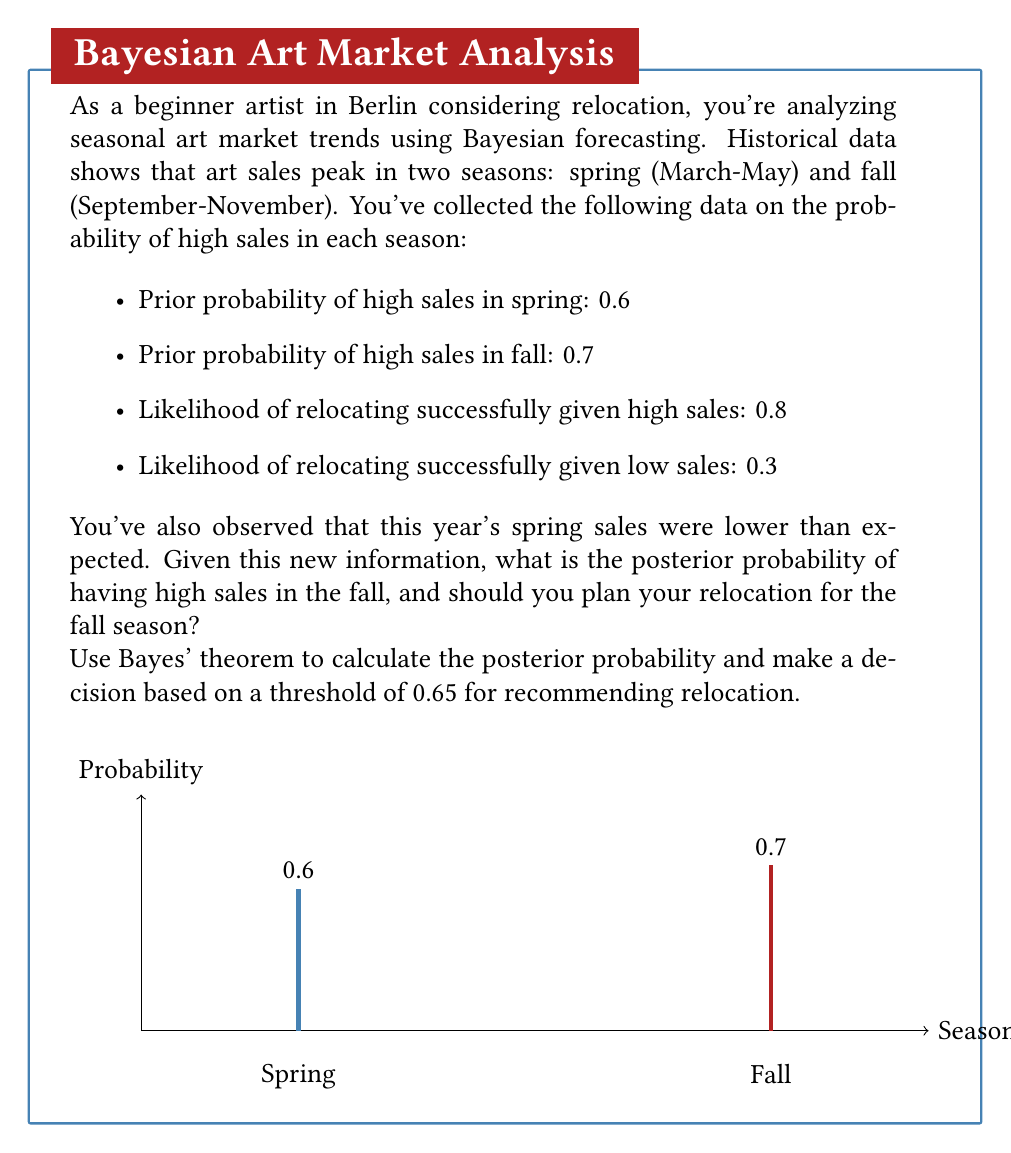Help me with this question. Let's approach this problem step-by-step using Bayes' theorem:

1) Define our events:
   A: High sales in fall
   B: Lower than expected sales in spring

2) We need to calculate P(A|B) using Bayes' theorem:

   $$P(A|B) = \frac{P(B|A)P(A)}{P(B)}$$

3) We know:
   P(A) = 0.7 (prior probability of high sales in fall)
   P(B|A) = 1 - 0.6 = 0.4 (probability of low spring sales given high fall sales)
   
4) We need to calculate P(B):
   P(B) = P(B|A)P(A) + P(B|not A)P(not A)
        = 0.4 * 0.7 + 0.6 * 0.3
        = 0.28 + 0.18
        = 0.46

5) Now we can apply Bayes' theorem:

   $$P(A|B) = \frac{0.4 * 0.7}{0.46} \approx 0.6087$$

6) The posterior probability of high sales in fall, given lower spring sales, is approximately 0.6087 or 60.87%.

7) Decision making:
   Our threshold for recommending relocation is 0.65 (65%).
   0.6087 < 0.65, so based on this analysis, we should not recommend relocating in the fall season.
Answer: Posterior probability ≈ 0.6087; Do not relocate in fall. 